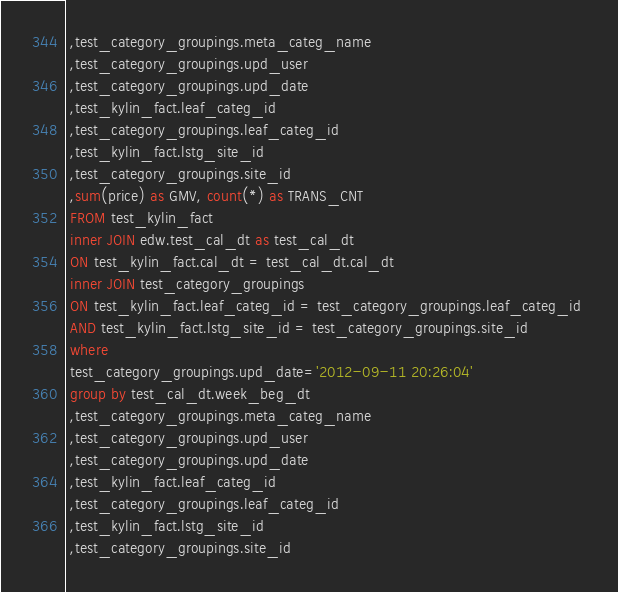<code> <loc_0><loc_0><loc_500><loc_500><_SQL_> ,test_category_groupings.meta_categ_name 
 ,test_category_groupings.upd_user 
 ,test_category_groupings.upd_date 
 ,test_kylin_fact.leaf_categ_id 
 ,test_category_groupings.leaf_categ_id 
 ,test_kylin_fact.lstg_site_id 
 ,test_category_groupings.site_id 
 ,sum(price) as GMV, count(*) as TRANS_CNT 
 FROM test_kylin_fact 
 inner JOIN edw.test_cal_dt as test_cal_dt 
 ON test_kylin_fact.cal_dt = test_cal_dt.cal_dt 
 inner JOIN test_category_groupings 
 ON test_kylin_fact.leaf_categ_id = test_category_groupings.leaf_categ_id 
 AND test_kylin_fact.lstg_site_id = test_category_groupings.site_id 
 where 
 test_category_groupings.upd_date='2012-09-11 20:26:04' 
 group by test_cal_dt.week_beg_dt 
 ,test_category_groupings.meta_categ_name 
 ,test_category_groupings.upd_user 
 ,test_category_groupings.upd_date 
 ,test_kylin_fact.leaf_categ_id 
 ,test_category_groupings.leaf_categ_id 
 ,test_kylin_fact.lstg_site_id 
 ,test_category_groupings.site_id 
</code> 